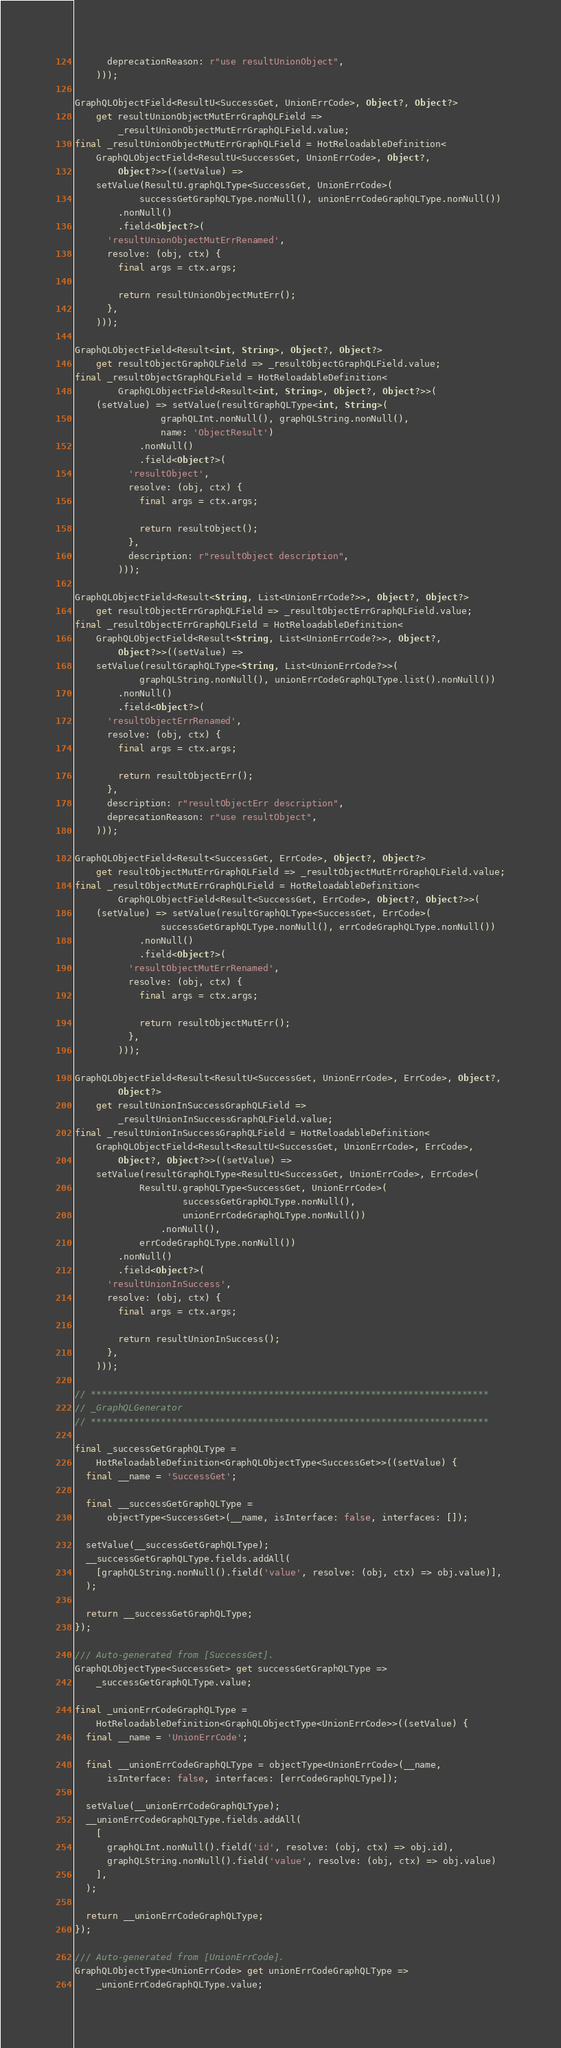Convert code to text. <code><loc_0><loc_0><loc_500><loc_500><_Dart_>      deprecationReason: r"use resultUnionObject",
    )));

GraphQLObjectField<ResultU<SuccessGet, UnionErrCode>, Object?, Object?>
    get resultUnionObjectMutErrGraphQLField =>
        _resultUnionObjectMutErrGraphQLField.value;
final _resultUnionObjectMutErrGraphQLField = HotReloadableDefinition<
    GraphQLObjectField<ResultU<SuccessGet, UnionErrCode>, Object?,
        Object?>>((setValue) =>
    setValue(ResultU.graphQLType<SuccessGet, UnionErrCode>(
            successGetGraphQLType.nonNull(), unionErrCodeGraphQLType.nonNull())
        .nonNull()
        .field<Object?>(
      'resultUnionObjectMutErrRenamed',
      resolve: (obj, ctx) {
        final args = ctx.args;

        return resultUnionObjectMutErr();
      },
    )));

GraphQLObjectField<Result<int, String>, Object?, Object?>
    get resultObjectGraphQLField => _resultObjectGraphQLField.value;
final _resultObjectGraphQLField = HotReloadableDefinition<
        GraphQLObjectField<Result<int, String>, Object?, Object?>>(
    (setValue) => setValue(resultGraphQLType<int, String>(
                graphQLInt.nonNull(), graphQLString.nonNull(),
                name: 'ObjectResult')
            .nonNull()
            .field<Object?>(
          'resultObject',
          resolve: (obj, ctx) {
            final args = ctx.args;

            return resultObject();
          },
          description: r"resultObject description",
        )));

GraphQLObjectField<Result<String, List<UnionErrCode?>>, Object?, Object?>
    get resultObjectErrGraphQLField => _resultObjectErrGraphQLField.value;
final _resultObjectErrGraphQLField = HotReloadableDefinition<
    GraphQLObjectField<Result<String, List<UnionErrCode?>>, Object?,
        Object?>>((setValue) =>
    setValue(resultGraphQLType<String, List<UnionErrCode?>>(
            graphQLString.nonNull(), unionErrCodeGraphQLType.list().nonNull())
        .nonNull()
        .field<Object?>(
      'resultObjectErrRenamed',
      resolve: (obj, ctx) {
        final args = ctx.args;

        return resultObjectErr();
      },
      description: r"resultObjectErr description",
      deprecationReason: r"use resultObject",
    )));

GraphQLObjectField<Result<SuccessGet, ErrCode>, Object?, Object?>
    get resultObjectMutErrGraphQLField => _resultObjectMutErrGraphQLField.value;
final _resultObjectMutErrGraphQLField = HotReloadableDefinition<
        GraphQLObjectField<Result<SuccessGet, ErrCode>, Object?, Object?>>(
    (setValue) => setValue(resultGraphQLType<SuccessGet, ErrCode>(
                successGetGraphQLType.nonNull(), errCodeGraphQLType.nonNull())
            .nonNull()
            .field<Object?>(
          'resultObjectMutErrRenamed',
          resolve: (obj, ctx) {
            final args = ctx.args;

            return resultObjectMutErr();
          },
        )));

GraphQLObjectField<Result<ResultU<SuccessGet, UnionErrCode>, ErrCode>, Object?,
        Object?>
    get resultUnionInSuccessGraphQLField =>
        _resultUnionInSuccessGraphQLField.value;
final _resultUnionInSuccessGraphQLField = HotReloadableDefinition<
    GraphQLObjectField<Result<ResultU<SuccessGet, UnionErrCode>, ErrCode>,
        Object?, Object?>>((setValue) =>
    setValue(resultGraphQLType<ResultU<SuccessGet, UnionErrCode>, ErrCode>(
            ResultU.graphQLType<SuccessGet, UnionErrCode>(
                    successGetGraphQLType.nonNull(),
                    unionErrCodeGraphQLType.nonNull())
                .nonNull(),
            errCodeGraphQLType.nonNull())
        .nonNull()
        .field<Object?>(
      'resultUnionInSuccess',
      resolve: (obj, ctx) {
        final args = ctx.args;

        return resultUnionInSuccess();
      },
    )));

// **************************************************************************
// _GraphQLGenerator
// **************************************************************************

final _successGetGraphQLType =
    HotReloadableDefinition<GraphQLObjectType<SuccessGet>>((setValue) {
  final __name = 'SuccessGet';

  final __successGetGraphQLType =
      objectType<SuccessGet>(__name, isInterface: false, interfaces: []);

  setValue(__successGetGraphQLType);
  __successGetGraphQLType.fields.addAll(
    [graphQLString.nonNull().field('value', resolve: (obj, ctx) => obj.value)],
  );

  return __successGetGraphQLType;
});

/// Auto-generated from [SuccessGet].
GraphQLObjectType<SuccessGet> get successGetGraphQLType =>
    _successGetGraphQLType.value;

final _unionErrCodeGraphQLType =
    HotReloadableDefinition<GraphQLObjectType<UnionErrCode>>((setValue) {
  final __name = 'UnionErrCode';

  final __unionErrCodeGraphQLType = objectType<UnionErrCode>(__name,
      isInterface: false, interfaces: [errCodeGraphQLType]);

  setValue(__unionErrCodeGraphQLType);
  __unionErrCodeGraphQLType.fields.addAll(
    [
      graphQLInt.nonNull().field('id', resolve: (obj, ctx) => obj.id),
      graphQLString.nonNull().field('value', resolve: (obj, ctx) => obj.value)
    ],
  );

  return __unionErrCodeGraphQLType;
});

/// Auto-generated from [UnionErrCode].
GraphQLObjectType<UnionErrCode> get unionErrCodeGraphQLType =>
    _unionErrCodeGraphQLType.value;
</code> 